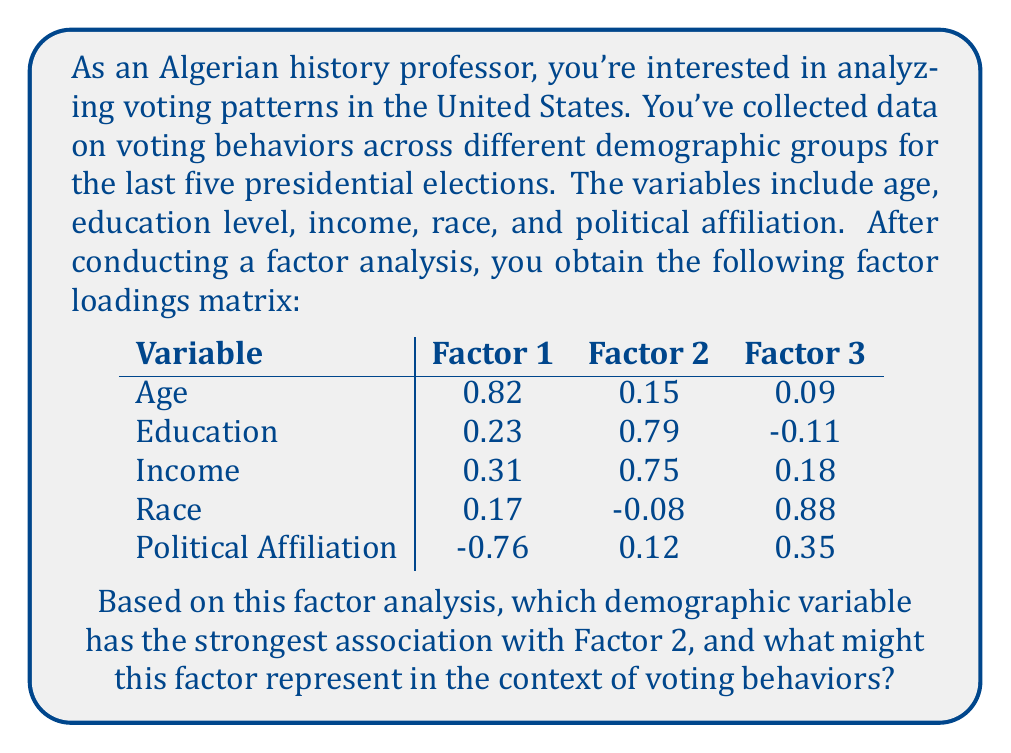Solve this math problem. To answer this question, we need to follow these steps:

1. Understand factor loadings:
   Factor loadings represent the correlation between each variable and the underlying factor. The higher the absolute value of the loading, the stronger the association.

2. Identify the highest loading for Factor 2:
   Looking at the Factor 2 column, we see:
   Age: 0.15
   Education: 0.79
   Income: 0.75
   Race: -0.08
   Political Affiliation: 0.12

   The highest absolute value is 0.79 for Education.

3. Interpret Factor 2:
   Factor 2 has high positive loadings for both Education (0.79) and Income (0.75). This suggests that Factor 2 might represent socioeconomic status.

4. Context in voting behaviors:
   In the context of voting behaviors, a factor representing socioeconomic status could indicate that education level and income are closely related and play a significant role in shaping voting patterns. This aligns with research showing that socioeconomic status can influence political preferences and engagement.

5. Significance for an Algerian history professor:
   As an Algerian professor teaching in the US, this finding could be particularly interesting for comparative studies between voting behaviors in different countries or for understanding the complexities of the American political landscape.
Answer: Education (loading: 0.79); Factor 2 likely represents socioeconomic status. 